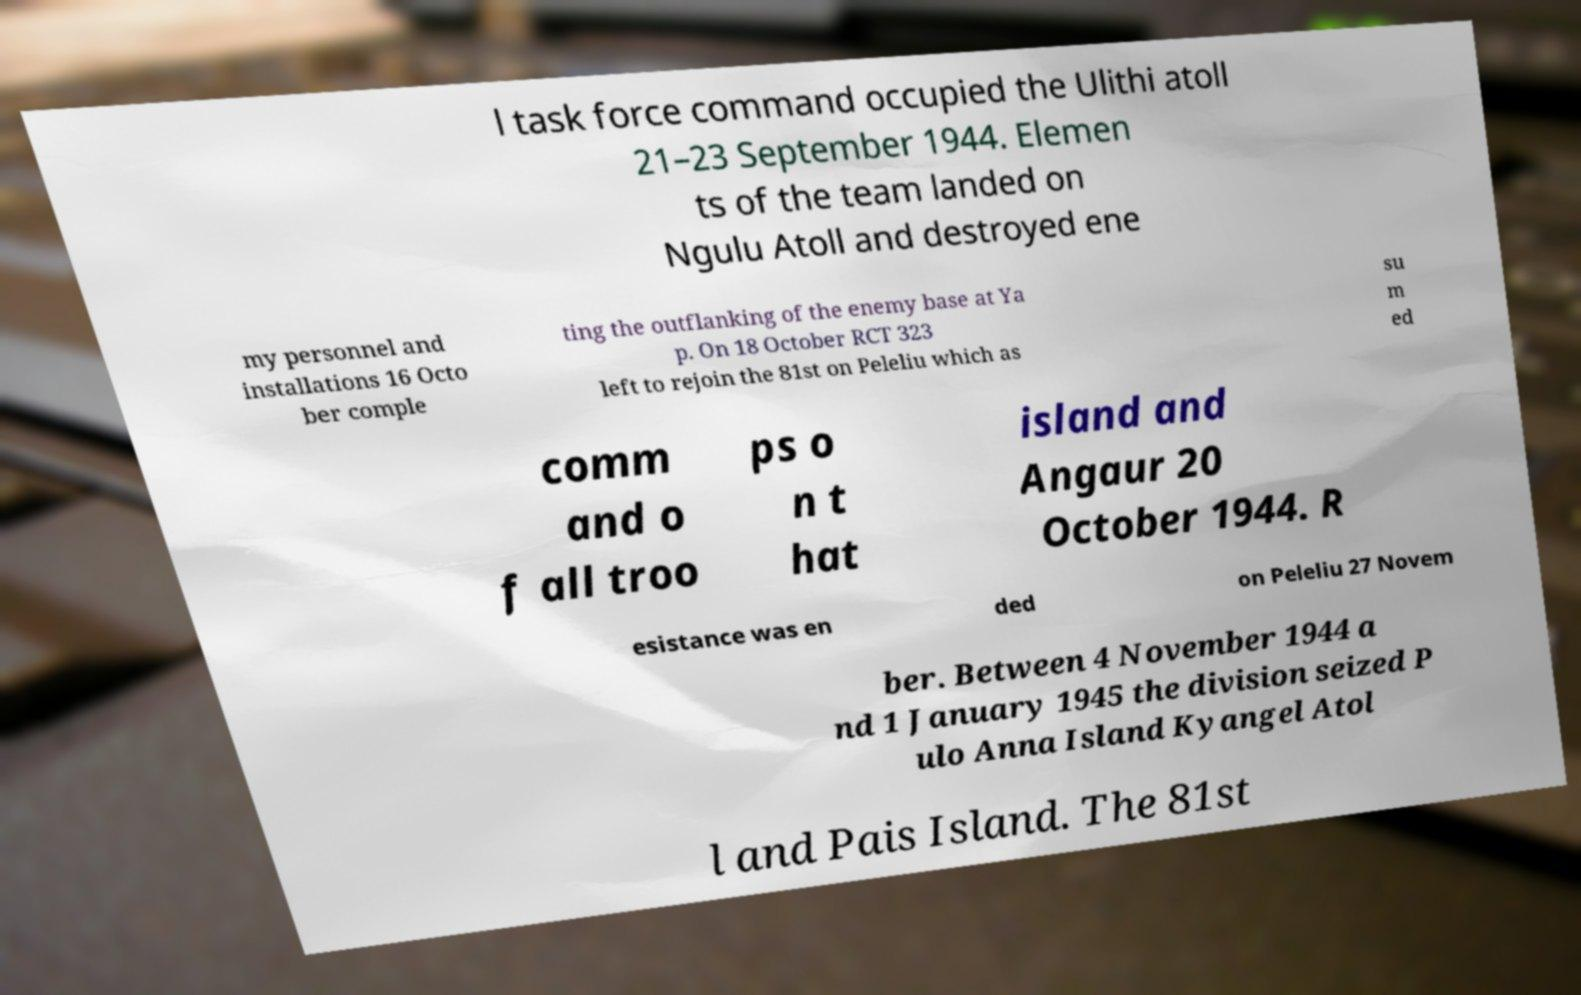I need the written content from this picture converted into text. Can you do that? l task force command occupied the Ulithi atoll 21–23 September 1944. Elemen ts of the team landed on Ngulu Atoll and destroyed ene my personnel and installations 16 Octo ber comple ting the outflanking of the enemy base at Ya p. On 18 October RCT 323 left to rejoin the 81st on Peleliu which as su m ed comm and o f all troo ps o n t hat island and Angaur 20 October 1944. R esistance was en ded on Peleliu 27 Novem ber. Between 4 November 1944 a nd 1 January 1945 the division seized P ulo Anna Island Kyangel Atol l and Pais Island. The 81st 